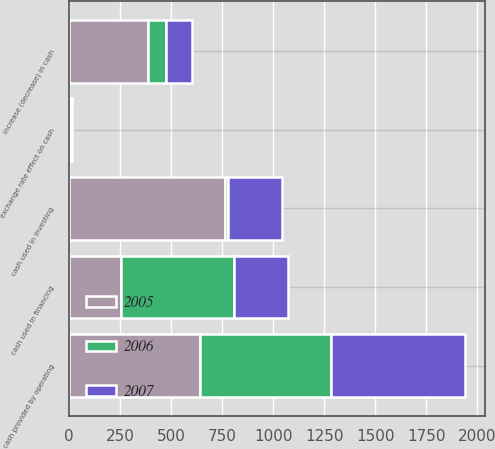<chart> <loc_0><loc_0><loc_500><loc_500><stacked_bar_chart><ecel><fcel>cash provided by operating<fcel>cash used in investing<fcel>cash used in financing<fcel>exchange rate effect on cash<fcel>increase (decrease) in cash<nl><fcel>2007<fcel>655.3<fcel>265.6<fcel>266.8<fcel>5.3<fcel>128.2<nl><fcel>2006<fcel>643.4<fcel>11.9<fcel>550.1<fcel>4.1<fcel>85.5<nl><fcel>2005<fcel>641.6<fcel>766.7<fcel>257.2<fcel>7.8<fcel>390.1<nl></chart> 